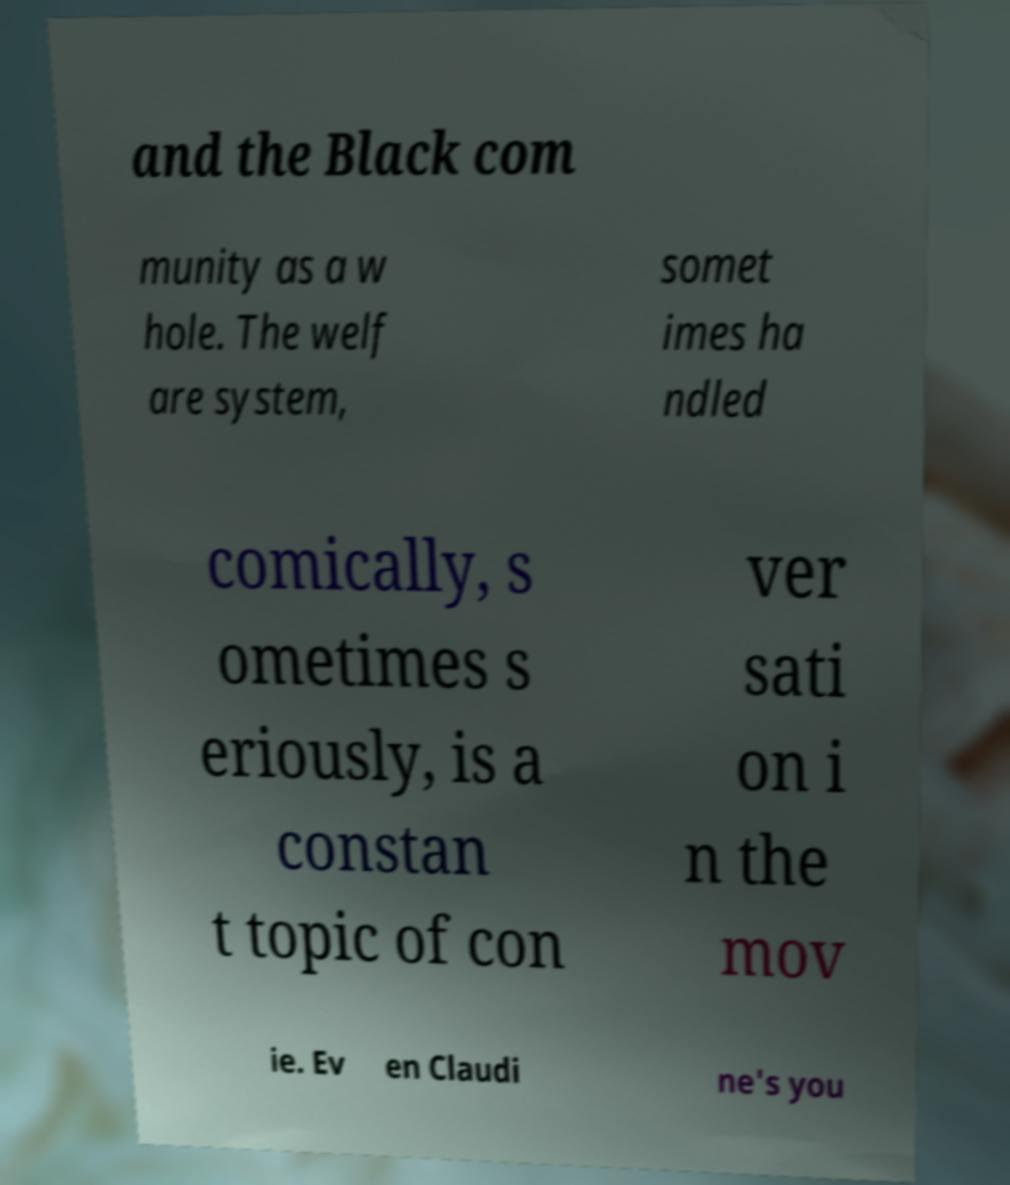For documentation purposes, I need the text within this image transcribed. Could you provide that? and the Black com munity as a w hole. The welf are system, somet imes ha ndled comically, s ometimes s eriously, is a constan t topic of con ver sati on i n the mov ie. Ev en Claudi ne's you 